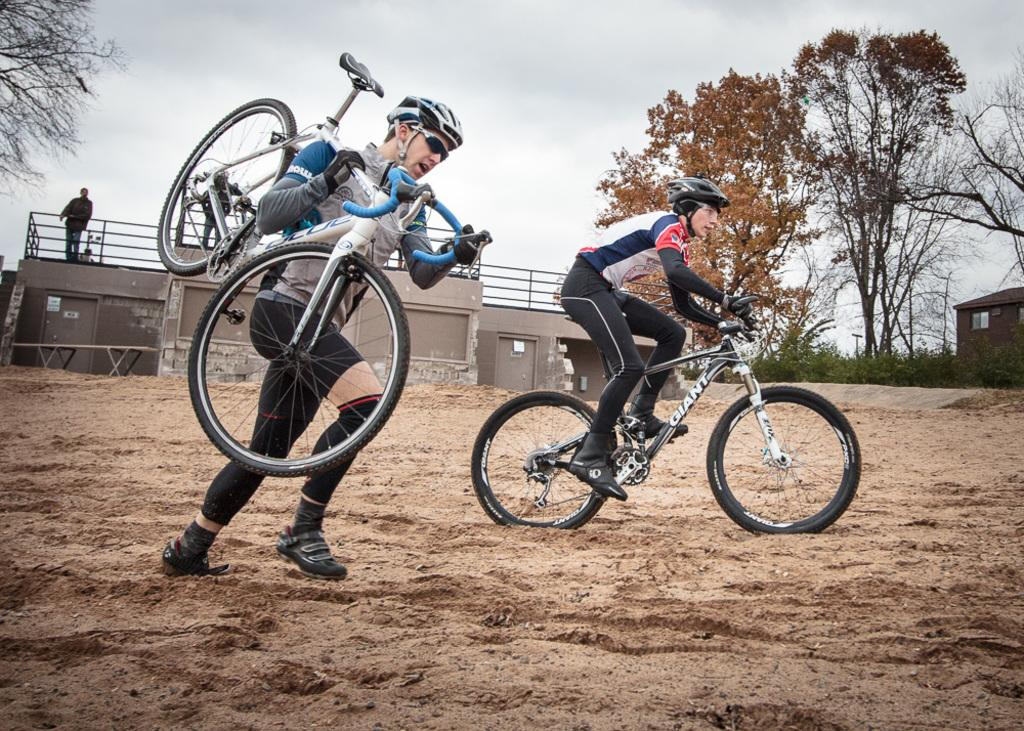What is the main activity of the person in the image? There is a person riding a bicycle in the image. What is the other person in the image doing? Another person is holding a bicycle in the image. What can be seen in the background of the image? There are buildings, at least one person, trees, and the sky visible in the background of the image. How many matches are being used to light the bicycle in the image? There are no matches or lighting of bicycles present in the image. What type of ducks can be seen swimming in the background of the image? There are no ducks present in the image; it features people riding and holding bicycles with a background of buildings, trees, and the sky. 